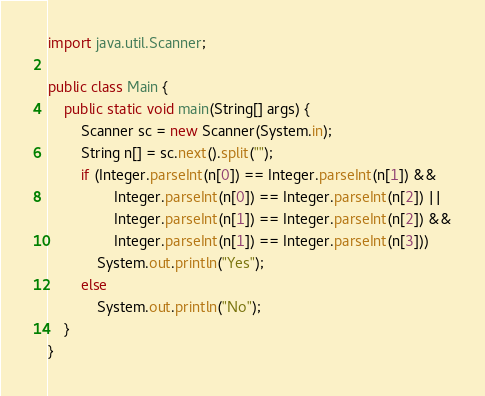<code> <loc_0><loc_0><loc_500><loc_500><_Java_>import java.util.Scanner;

public class Main {
	public static void main(String[] args) {
		Scanner sc = new Scanner(System.in);
		String n[] = sc.next().split("");
		if (Integer.parseInt(n[0]) == Integer.parseInt(n[1]) &&
				Integer.parseInt(n[0]) == Integer.parseInt(n[2]) ||
				Integer.parseInt(n[1]) == Integer.parseInt(n[2]) &&
				Integer.parseInt(n[1]) == Integer.parseInt(n[3]))
			System.out.println("Yes");
		else
			System.out.println("No");
	}
}</code> 